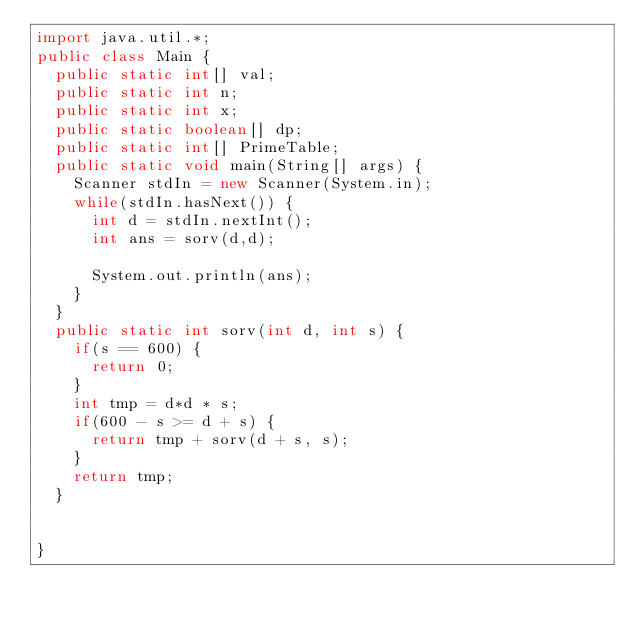<code> <loc_0><loc_0><loc_500><loc_500><_Java_>import java.util.*;
public class Main {
	public static int[] val;
	public static int n;
	public static int x;
	public static boolean[] dp;
	public static int[] PrimeTable;
	public static void main(String[] args) {
		Scanner stdIn = new Scanner(System.in);
		while(stdIn.hasNext()) {
			int d = stdIn.nextInt();
			int ans = sorv(d,d);
		
			System.out.println(ans);
		}
	}
	public static int sorv(int d, int s) {
		if(s == 600) {
			return 0;
		}
		int tmp = d*d * s;
		if(600 - s >= d + s) {
			return tmp + sorv(d + s, s);
		}
		return tmp;
	}

	
}</code> 